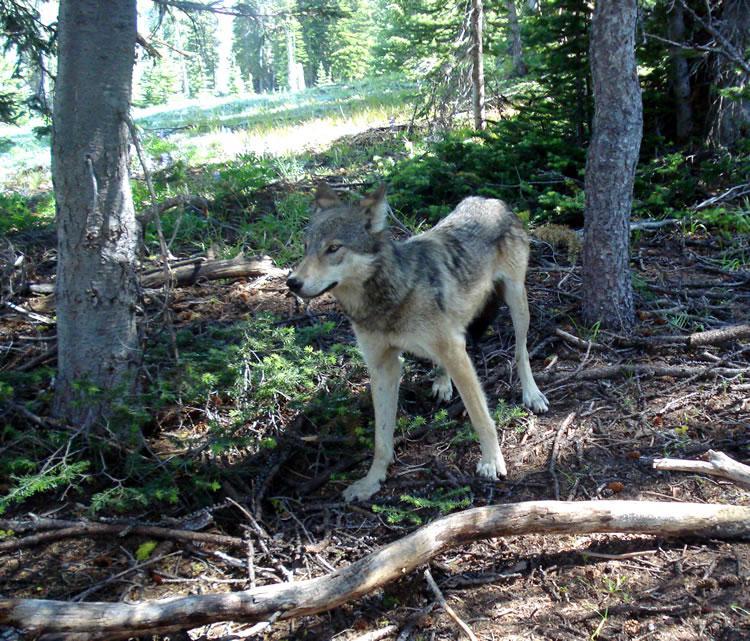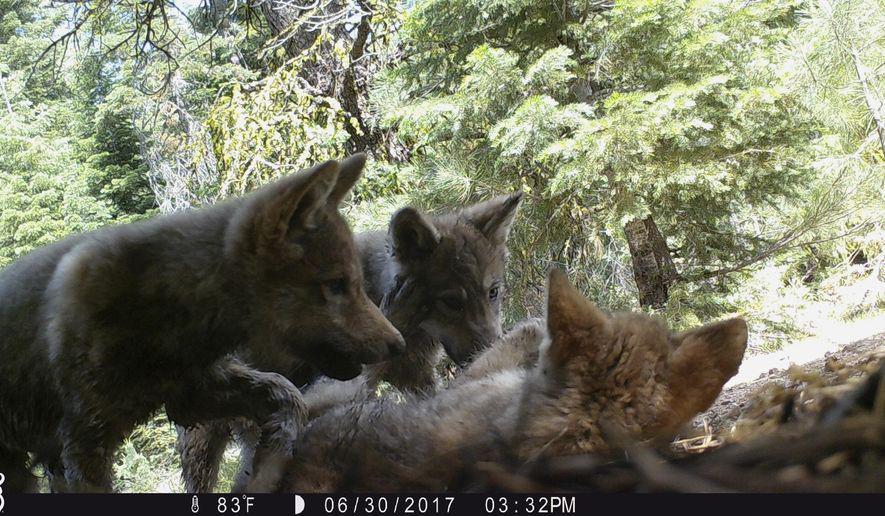The first image is the image on the left, the second image is the image on the right. Assess this claim about the two images: "The image on the left includes at least one adult wolf standing on all fours, and the image on the right includes three wolf pups.". Correct or not? Answer yes or no. Yes. 